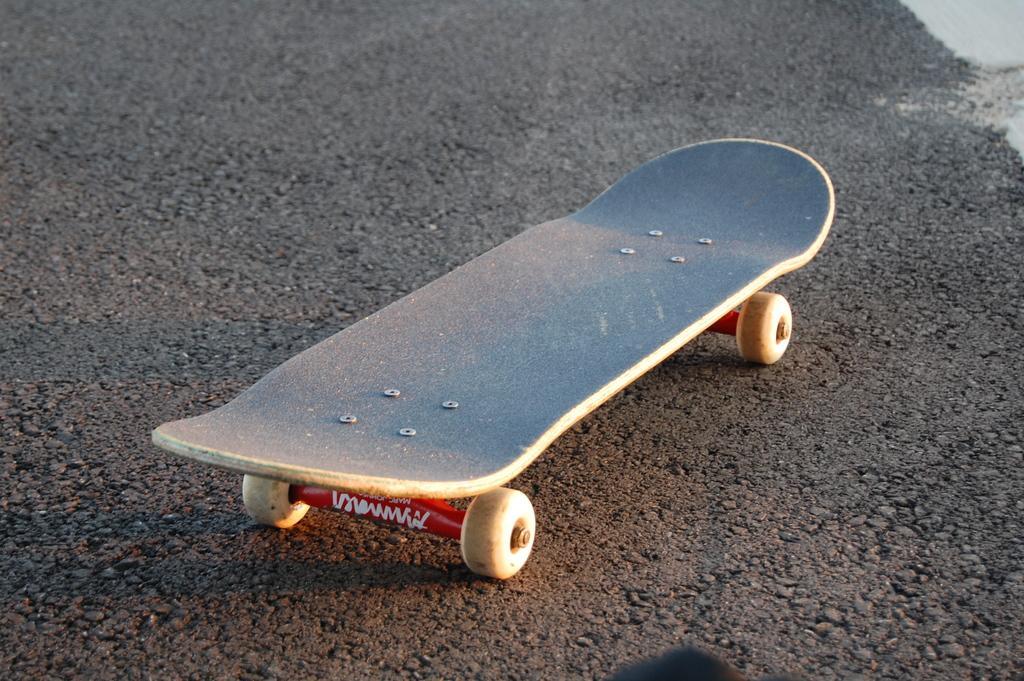Please provide a concise description of this image. In the center of the image we can see a skating board on the road. 